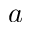<formula> <loc_0><loc_0><loc_500><loc_500>a</formula> 